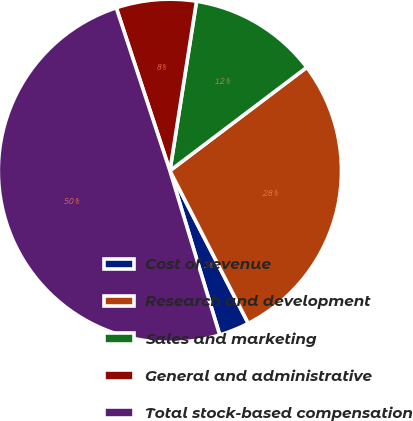Convert chart. <chart><loc_0><loc_0><loc_500><loc_500><pie_chart><fcel>Cost of revenue<fcel>Research and development<fcel>Sales and marketing<fcel>General and administrative<fcel>Total stock-based compensation<nl><fcel>2.86%<fcel>27.75%<fcel>12.22%<fcel>7.54%<fcel>49.63%<nl></chart> 